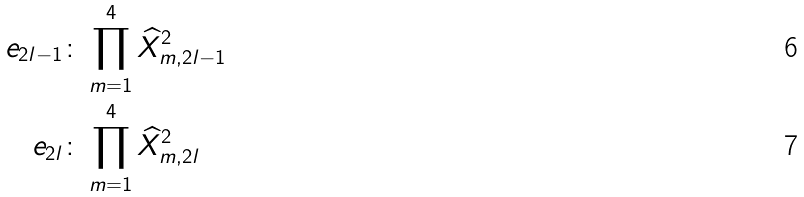<formula> <loc_0><loc_0><loc_500><loc_500>e _ { 2 l - 1 } & \colon \prod _ { m = 1 } ^ { 4 } \widehat { X } _ { m , 2 l - 1 } ^ { 2 } \\ e _ { 2 l } & \colon \prod _ { m = 1 } ^ { 4 } \widehat { X } _ { m , 2 l } ^ { 2 }</formula> 